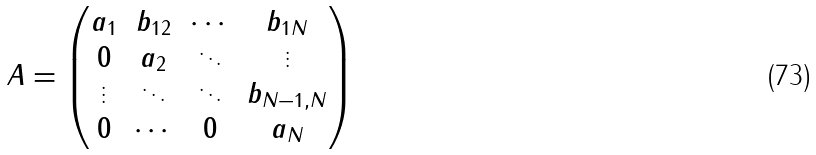<formula> <loc_0><loc_0><loc_500><loc_500>A = \left ( \begin{matrix} a _ { 1 } & b _ { 1 2 } & \cdots & b _ { 1 N } \\ 0 & a _ { 2 } & \ddots & \vdots \\ \vdots & \ddots & \ddots & b _ { N - 1 , N } \\ 0 & \cdots & 0 & a _ { N } \end{matrix} \right )</formula> 